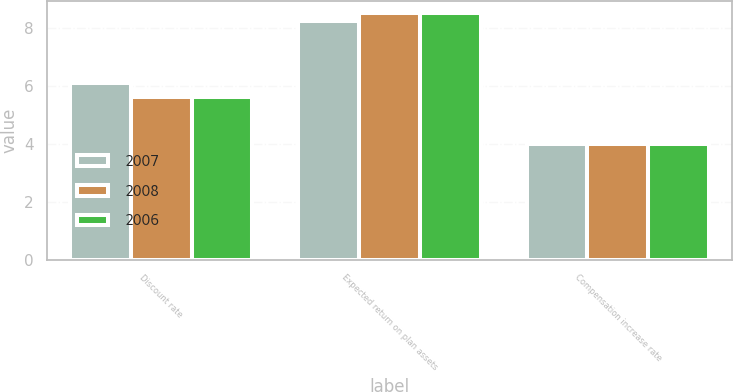Convert chart. <chart><loc_0><loc_0><loc_500><loc_500><stacked_bar_chart><ecel><fcel>Discount rate<fcel>Expected return on plan assets<fcel>Compensation increase rate<nl><fcel>2007<fcel>6.1<fcel>8.25<fcel>4<nl><fcel>2008<fcel>5.6<fcel>8.5<fcel>4<nl><fcel>2006<fcel>5.6<fcel>8.5<fcel>4<nl></chart> 